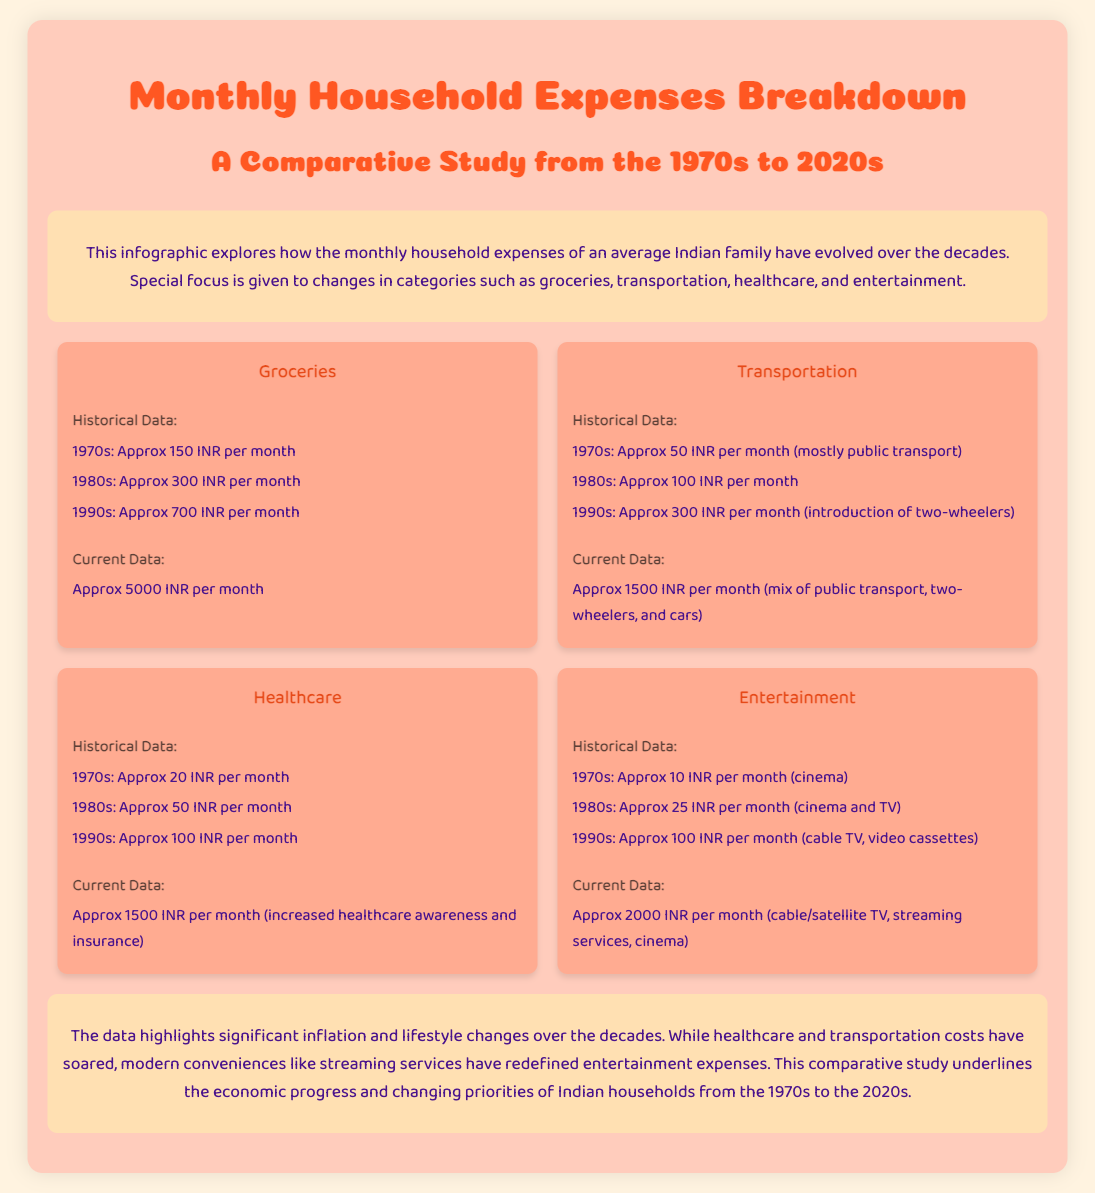What were the grocery expenses in the 1990s? The document states that grocery expenses were approximately 700 INR per month in the 1990s.
Answer: 700 INR What is the current cost of transportation? The current cost of transportation is stated as approximately 1500 INR per month in the document.
Answer: 1500 INR How much did entertainment cost in the 1970s? According to the document, entertainment expenses in the 1970s were approximately 10 INR per month.
Answer: 10 INR What is the percentage increase in monthly healthcare expenses from the 1970s to the current costs? The expenses increased from approximately 20 INR in the 1970s to approximately 1500 INR currently, indicating a significant increase.
Answer: Significant increase What expenses have increased the most according to this document? The document highlights that healthcare and transportation costs have soared.
Answer: Healthcare and transportation What category had a cost of 100 INR per month in the 1990s? The document mentions that the entertainment expenses were approximately 100 INR per month in the 1990s.
Answer: Entertainment How much did households spend on groceries in the 1980s? The document states that grocery expenses were approximately 300 INR per month in the 1980s.
Answer: 300 INR What is the overall theme of the infographic? The document discusses the evolution of monthly household expenses over the decades in India.
Answer: Evolution of household expenses What is the estimated monthly expense for entertainment currently? The current expense for entertainment is approximately 2000 INR per month as stated in the document.
Answer: 2000 INR 